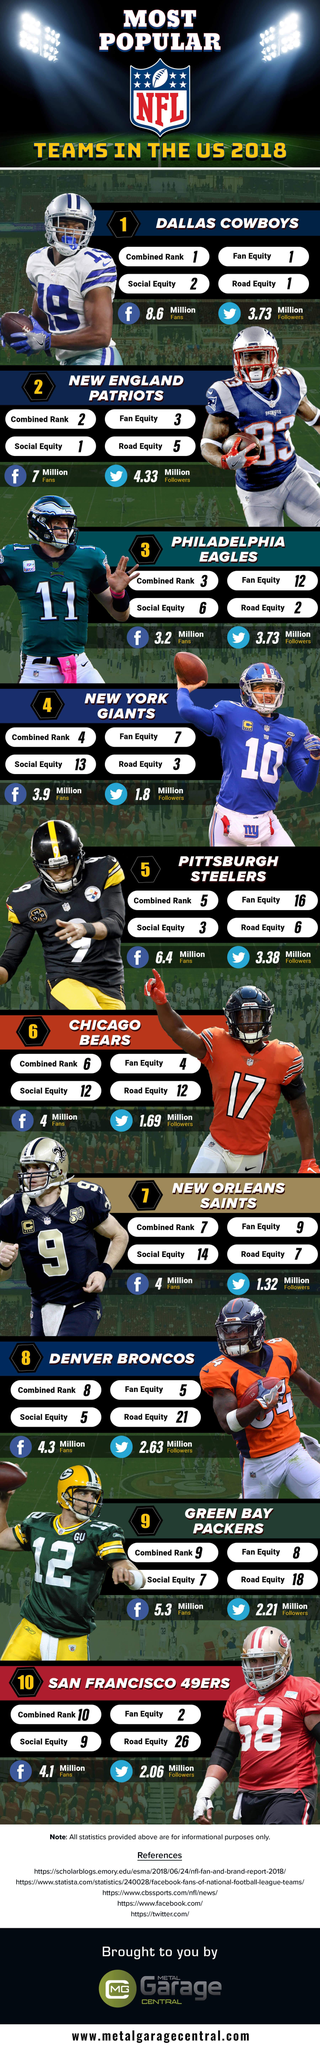List a handful of essential elements in this visual. According to a survey conducted in 2018, the New England Patriots have the most Twitter followers among the most popular NFL teams in the United States. According to the fan equity ranking in 2018, the Dallas Cowboys are the most popular and highly regarded NFL team in the United States, earning the top spot among the most popular teams in the country. The New England Patriots are the NFL team with the highest social equity ranking among the most popular teams in the United States in 2018. As of 2018, the Dallas Cowboys had approximately 3.73 million Twitter followers in the United States. The jersey number of the Green Bay Packers player depicted in this image is 12. 